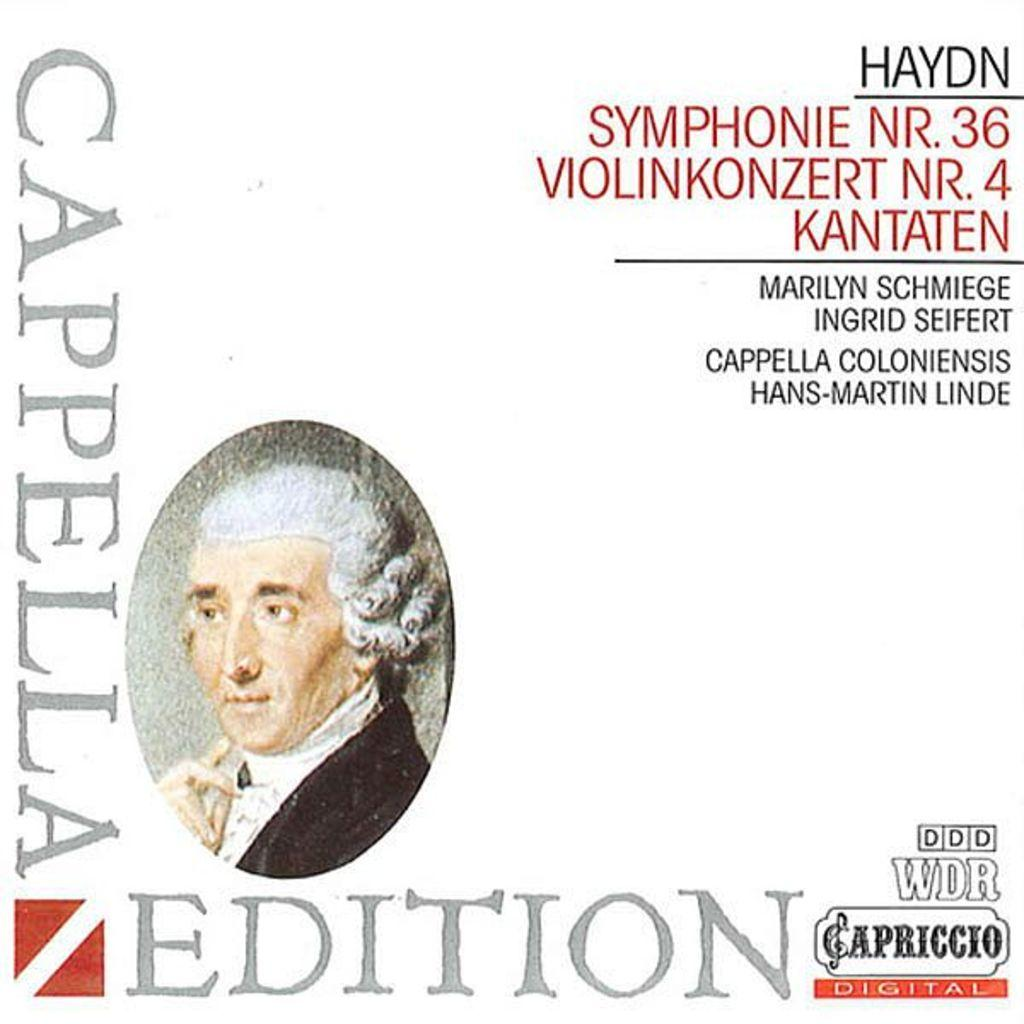What is the main subject of the image on the book? The image is a painting on a book, and the main subject is a person on the left side of the book. What else can be found on the book besides the painting? There is text written on the right side of the book. What religion is depicted in the painting on the book? There is no indication of any religion in the painting on the book; it simply features a person. What time of day does the painting on the book represent? The painting on the book does not represent any specific hour or time of day. 